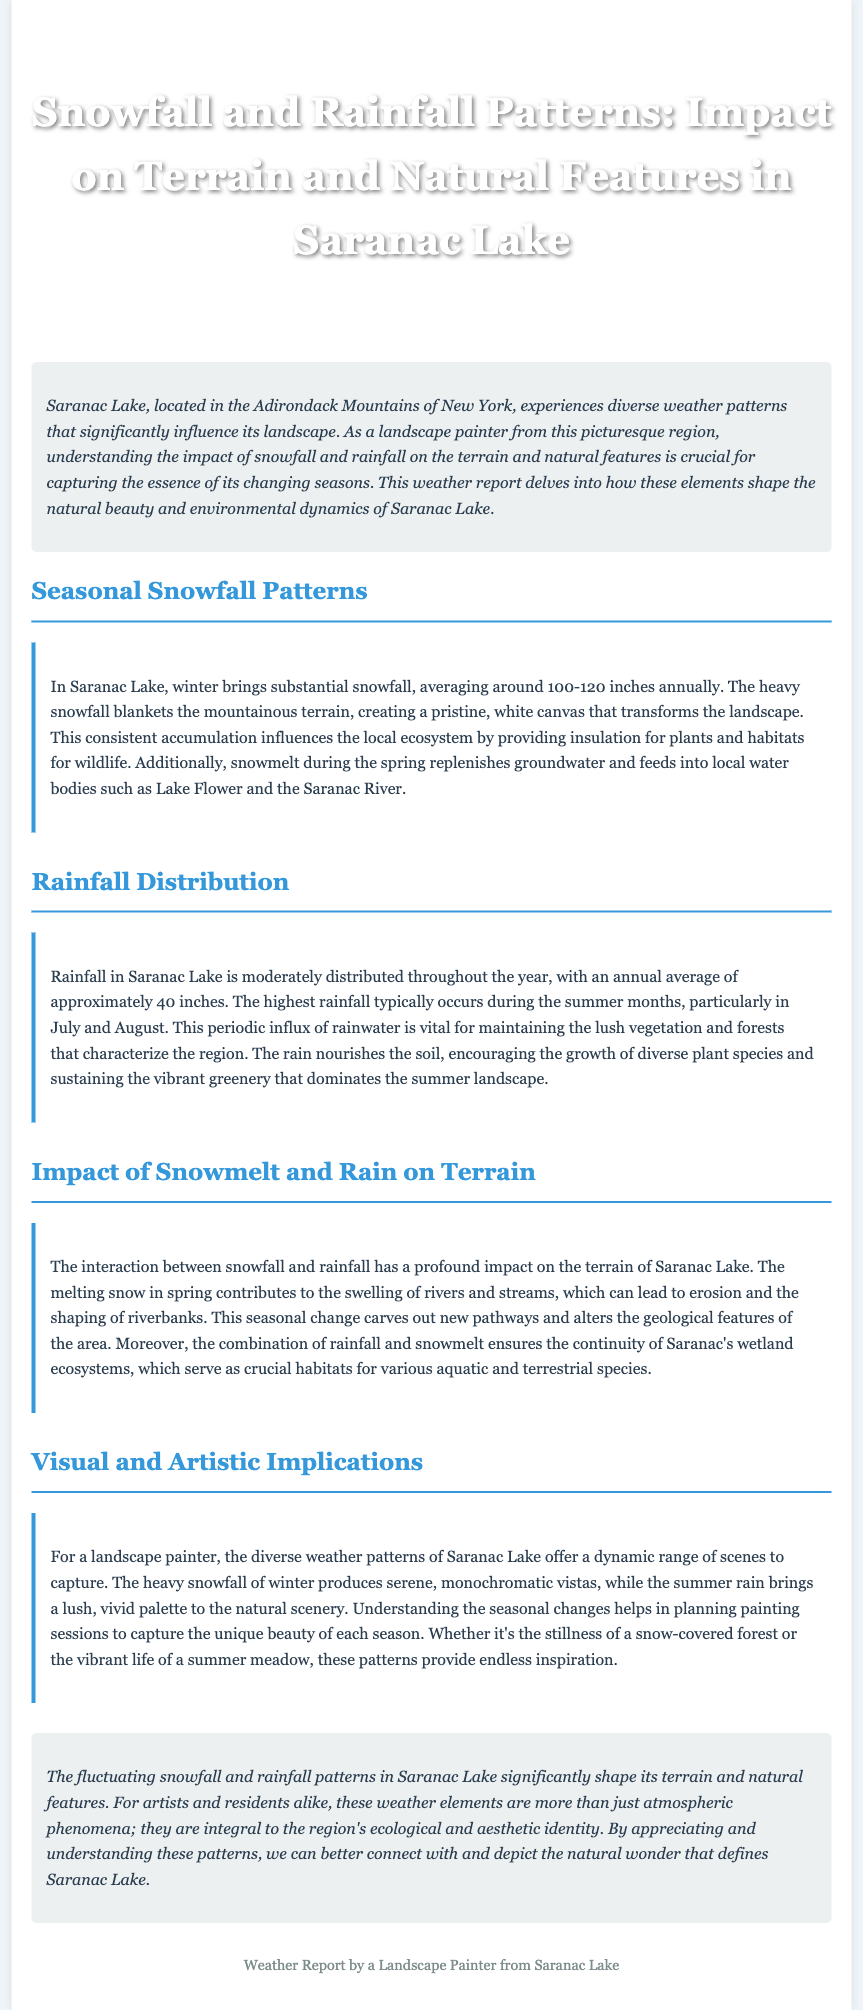What is the average annual snowfall in Saranac Lake? The document states that the average annual snowfall in Saranac Lake is around 100-120 inches.
Answer: 100-120 inches What is the annual average rainfall in Saranac Lake? The document mentions that the annual average rainfall in Saranac Lake is approximately 40 inches.
Answer: 40 inches During which months does the highest rainfall typically occur? According to the document, the highest rainfall typically occurs during the summer months, particularly in July and August.
Answer: July and August What are two natural bodies of water mentioned in relation to snowmelt? The document references Lake Flower and the Saranac River in connection with spring snowmelt.
Answer: Lake Flower and Saranac River How do snowfall and rainfall interact to affect terrain? The document explains that the interaction can lead to erosion and shaping of riverbanks due to swelling rivers and streams from melting snow and rainfall.
Answer: Erosion and shaping of riverbanks What visual implications do snowfall patterns have for landscape painters? The document states that heavy snowfall produces serene, monochromatic vistas for artists to capture.
Answer: Serene, monochromatic vistas What role does rain play in the vegetation of Saranac Lake? The document indicates that rainfall nourishes the soil, encouraging the growth of diverse plant species.
Answer: Encouraging the growth of diverse plant species What seasonal change contributes to the swelling of rivers and streams? The document highlights that melting snow in spring contributes to the swelling of rivers and streams.
Answer: Melting snow in spring What does the concluding paragraph emphasize about snowfall and rainfall patterns? The document concludes that these weather elements significantly shape the terrain and natural features of Saranac Lake.
Answer: Significantly shape the terrain and natural features 